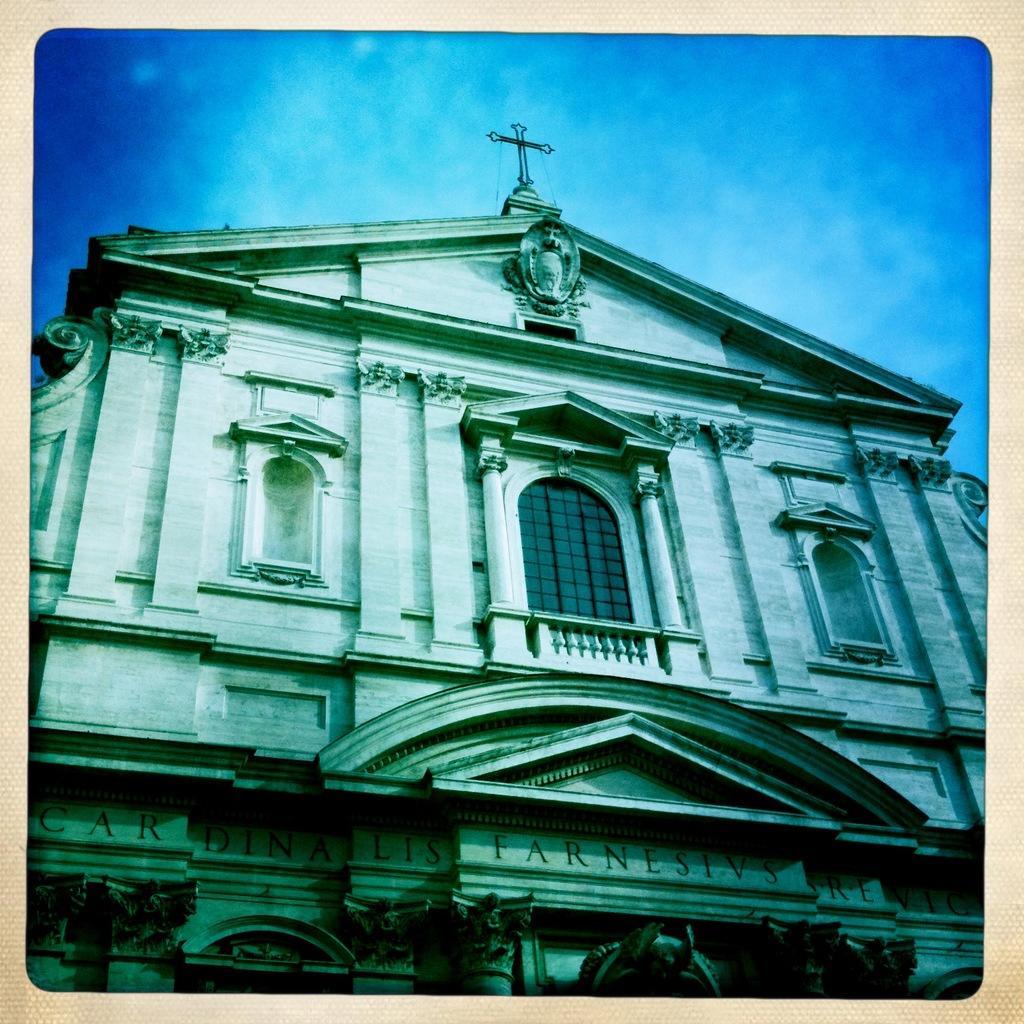Could you give a brief overview of what you see in this image? In the center of the image there is building. In the background we can see sky and clouds. 